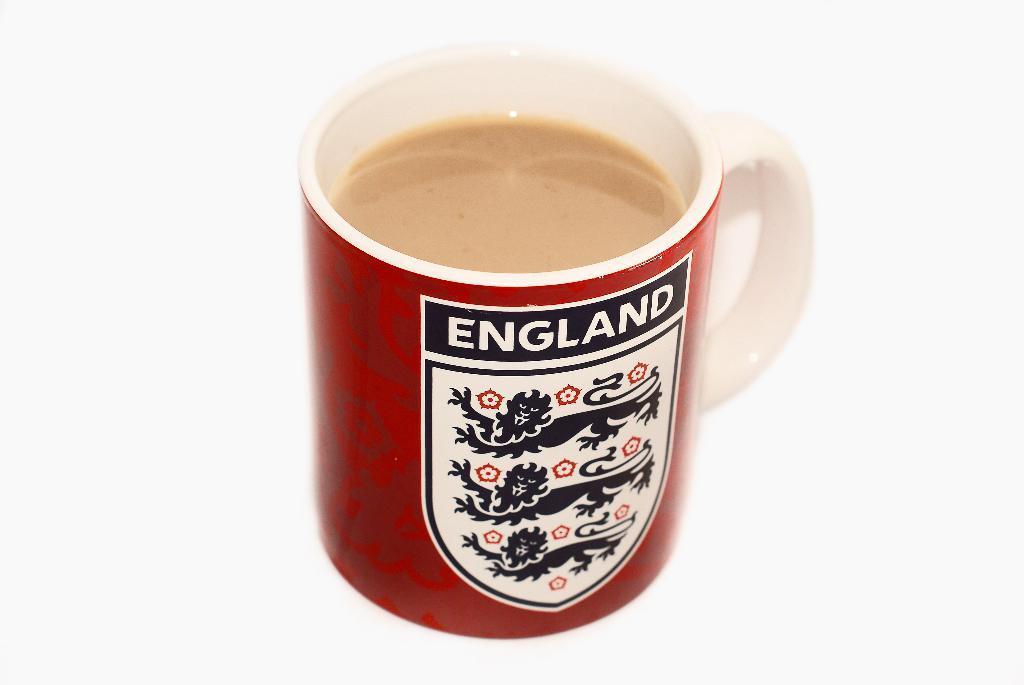In one or two sentences, can you explain what this image depicts? In this picture we can see a cup with drink in it and a sticker on it and in the background it is white color. 